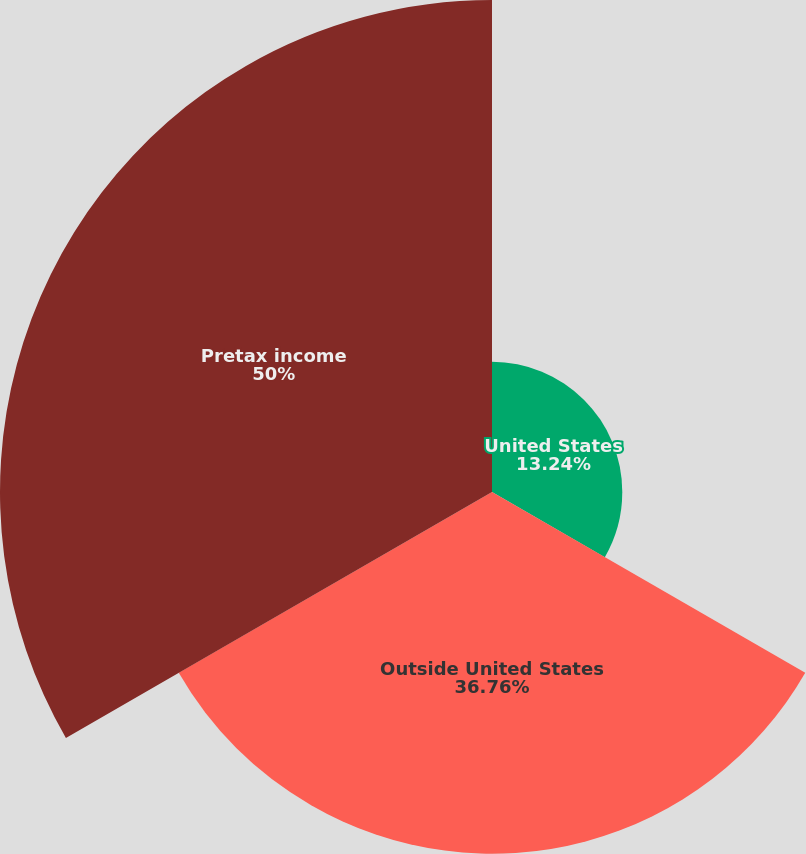<chart> <loc_0><loc_0><loc_500><loc_500><pie_chart><fcel>United States<fcel>Outside United States<fcel>Pretax income<nl><fcel>13.24%<fcel>36.76%<fcel>50.0%<nl></chart> 